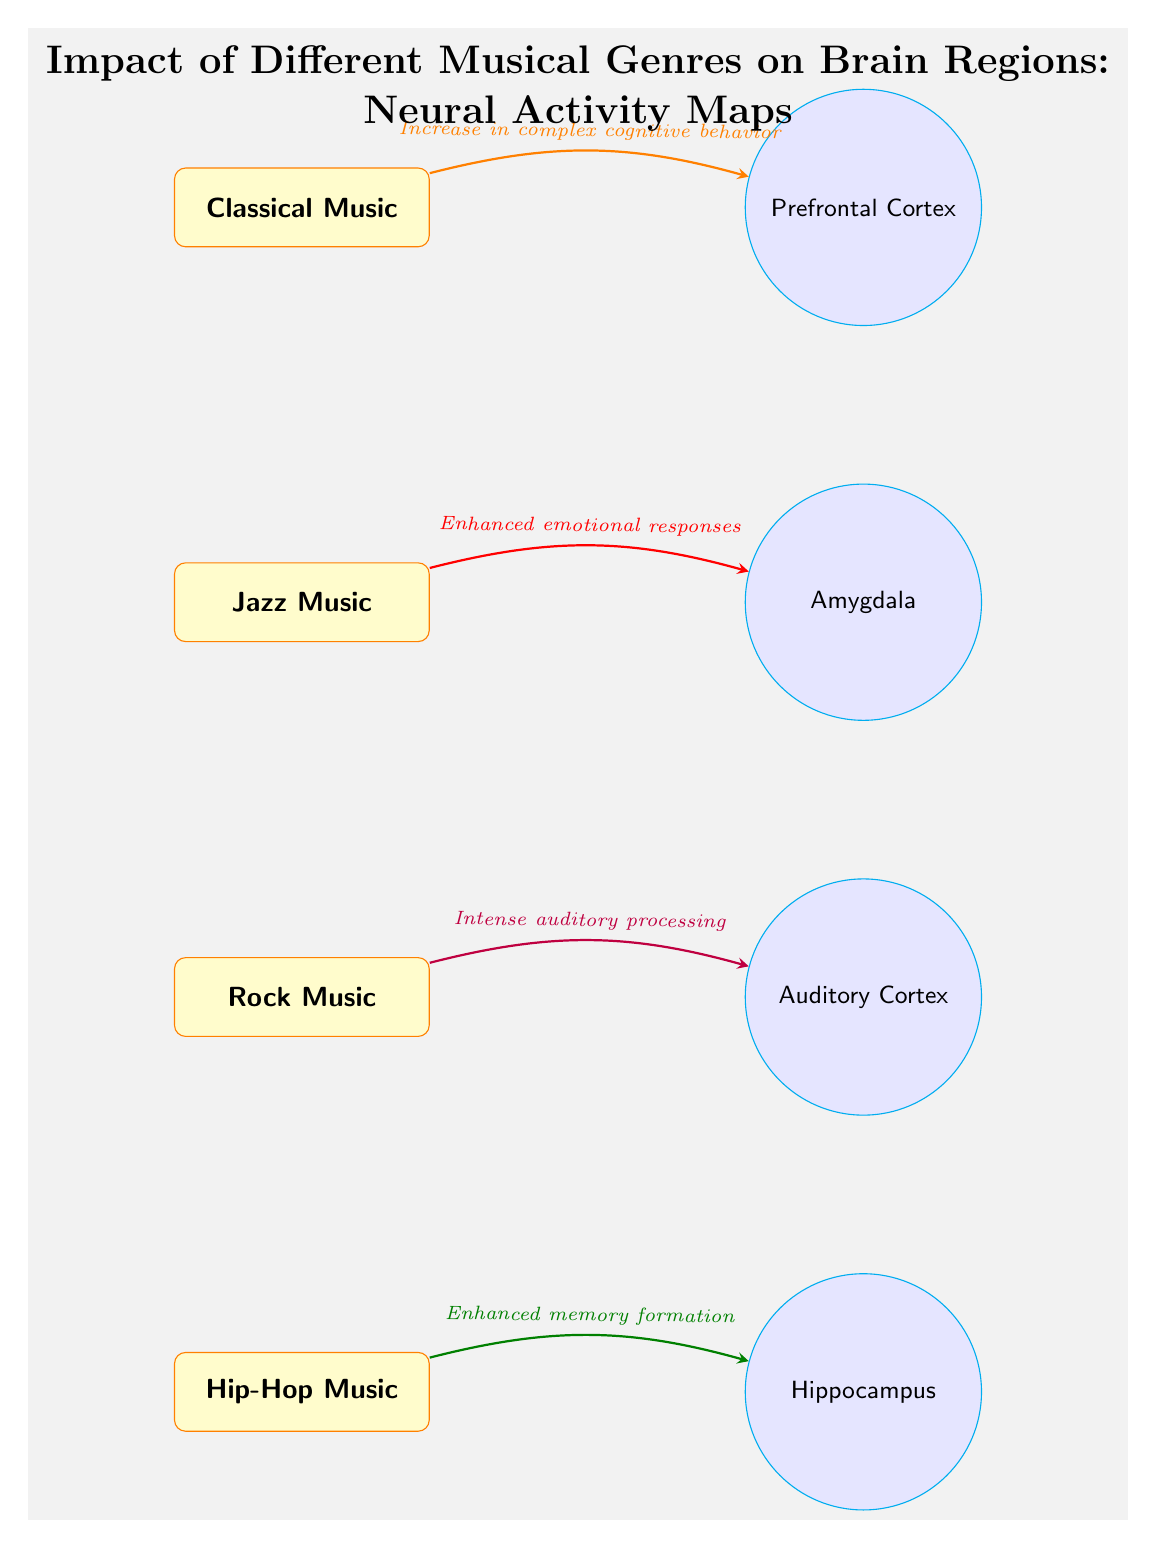What musical genre is linked to the Prefrontal Cortex? The arrow from the Classical Music genre points directly to the Prefrontal Cortex, indicating a relationship between them.
Answer: Classical Music Which brain region is associated with Hip-Hop Music? The arrow from Hip-Hop Music points directly to the Hippocampus, showcasing that this genre affects this brain region.
Answer: Hippocampus How many musical genres are represented in the diagram? The diagram shows four distinct musical genres: Classical, Jazz, Rock, and Hip-Hop, making a total of four.
Answer: 4 What cognitive behavior is increased by listening to Classical Music? The diagram states that listening to Classical Music leads to an "Increase in complex cognitive behavior," which is indicated by the label on the arrow pointing to the Prefrontal Cortex.
Answer: Increase in complex cognitive behavior Which brain region is impacted by Jazz Music, and what is the effect? The diagram specifies that Jazz Music influences the Amygdala, resulting in "Enhanced emotional responses," as indicated on the arrow leading to that brain region.
Answer: Amygdala; Enhanced emotional responses What is the flow direction of the influence from Rock Music to brain regions? The arrow indicating the relationship from Rock Music to the Auditory Cortex flows from the Rock Music genre towards the Auditory Cortex, illustrating the impact's direction.
Answer: Right Which musical genre is associated with "Intense auditory processing"? The arrow labeled "Intense auditory processing" points from Rock Music to the Auditory Cortex, establishing a direct connection.
Answer: Rock Music Identify the color used for the arrow pointing from Hip-Hop Music to the Hippocampus. The arrow from Hip-Hop Music to the Hippocampus is colored green with a shade denoted as 50% black, as described in the diagram's color coding.
Answer: green!50!black What background color is used in the diagram? The diagram's background is filled with a light gray color, specifically noted as gray shade 10.
Answer: gray!10 